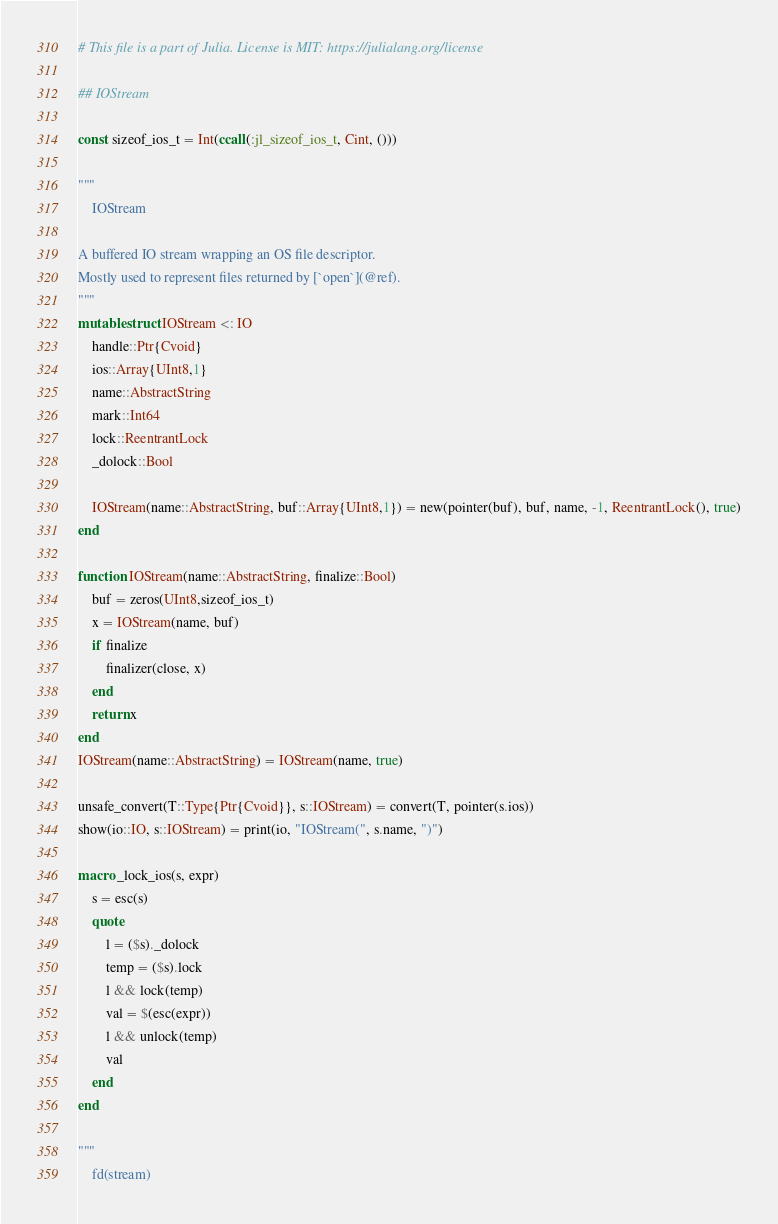Convert code to text. <code><loc_0><loc_0><loc_500><loc_500><_Julia_># This file is a part of Julia. License is MIT: https://julialang.org/license

## IOStream

const sizeof_ios_t = Int(ccall(:jl_sizeof_ios_t, Cint, ()))

"""
    IOStream

A buffered IO stream wrapping an OS file descriptor.
Mostly used to represent files returned by [`open`](@ref).
"""
mutable struct IOStream <: IO
    handle::Ptr{Cvoid}
    ios::Array{UInt8,1}
    name::AbstractString
    mark::Int64
    lock::ReentrantLock
    _dolock::Bool

    IOStream(name::AbstractString, buf::Array{UInt8,1}) = new(pointer(buf), buf, name, -1, ReentrantLock(), true)
end

function IOStream(name::AbstractString, finalize::Bool)
    buf = zeros(UInt8,sizeof_ios_t)
    x = IOStream(name, buf)
    if finalize
        finalizer(close, x)
    end
    return x
end
IOStream(name::AbstractString) = IOStream(name, true)

unsafe_convert(T::Type{Ptr{Cvoid}}, s::IOStream) = convert(T, pointer(s.ios))
show(io::IO, s::IOStream) = print(io, "IOStream(", s.name, ")")

macro _lock_ios(s, expr)
    s = esc(s)
    quote
        l = ($s)._dolock
        temp = ($s).lock
        l && lock(temp)
        val = $(esc(expr))
        l && unlock(temp)
        val
    end
end

"""
    fd(stream)
</code> 